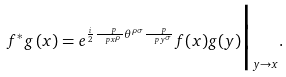Convert formula to latex. <formula><loc_0><loc_0><loc_500><loc_500>f ^ { * } g \, ( x ) = e ^ { \frac { i } { 2 } \frac { \ p } { \ p x ^ { \rho } } \theta ^ { \rho \sigma } \frac { \ p } { \ p y ^ { \sigma } } } f ( x ) g ( y ) \Big | _ { y \rightarrow x } .</formula> 